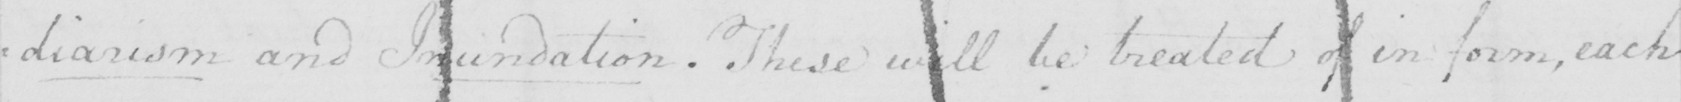Please provide the text content of this handwritten line. =diarism and Inundation . These will be treated of in form , each 